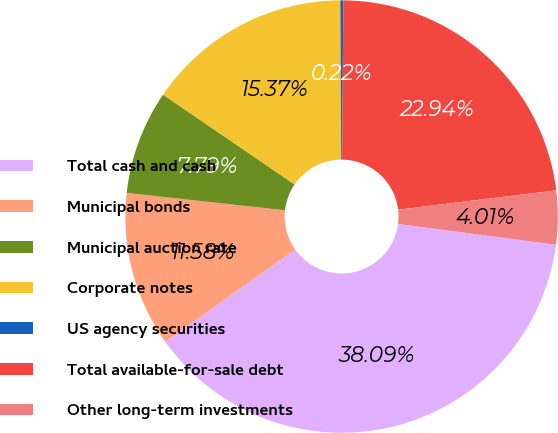<chart> <loc_0><loc_0><loc_500><loc_500><pie_chart><fcel>Total cash and cash<fcel>Municipal bonds<fcel>Municipal auction rate<fcel>Corporate notes<fcel>US agency securities<fcel>Total available-for-sale debt<fcel>Other long-term investments<nl><fcel>38.09%<fcel>11.58%<fcel>7.79%<fcel>15.37%<fcel>0.22%<fcel>22.94%<fcel>4.01%<nl></chart> 